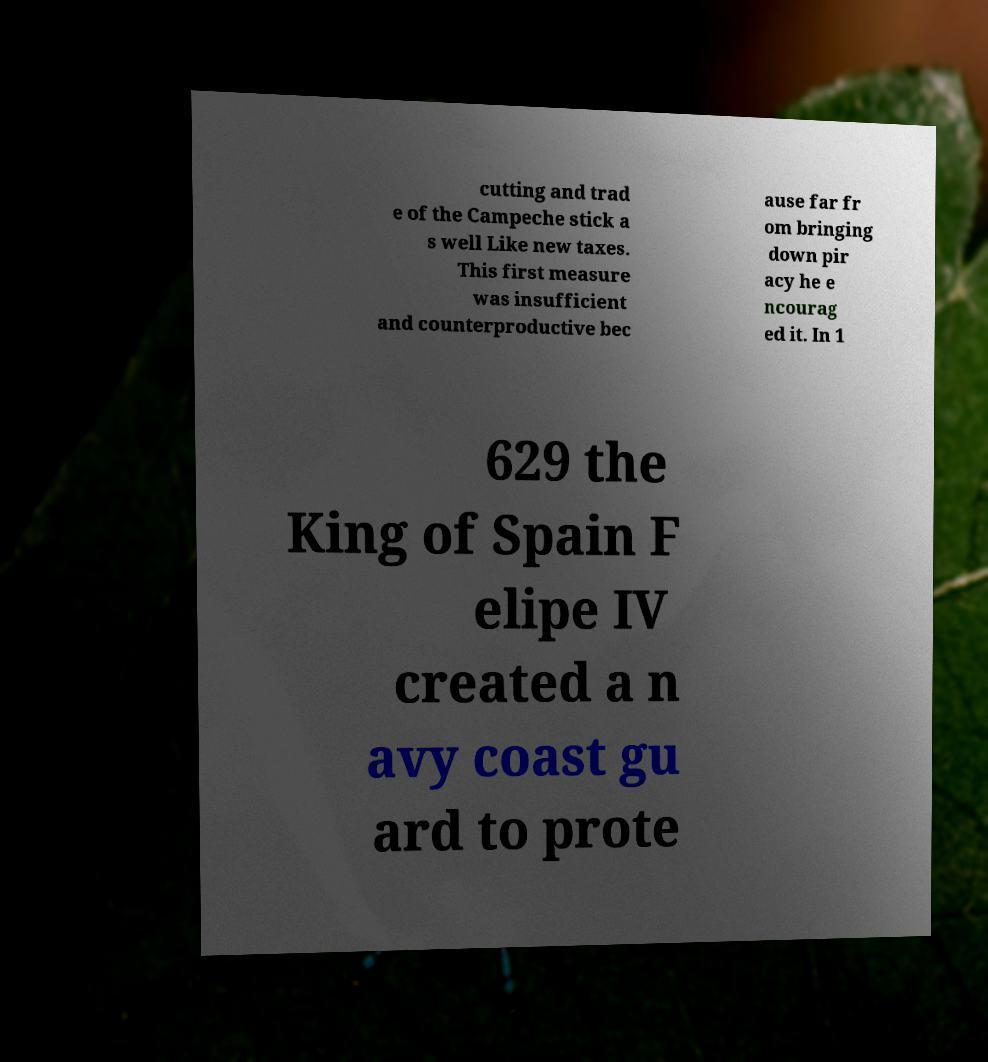For documentation purposes, I need the text within this image transcribed. Could you provide that? cutting and trad e of the Campeche stick a s well Like new taxes. This first measure was insufficient and counterproductive bec ause far fr om bringing down pir acy he e ncourag ed it. In 1 629 the King of Spain F elipe IV created a n avy coast gu ard to prote 